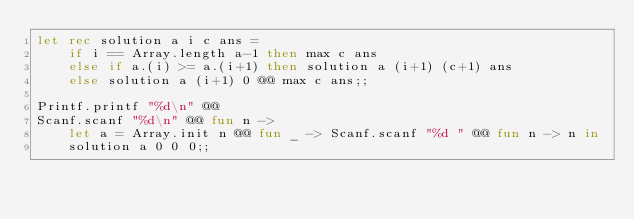<code> <loc_0><loc_0><loc_500><loc_500><_OCaml_>let rec solution a i c ans =
    if i == Array.length a-1 then max c ans
    else if a.(i) >= a.(i+1) then solution a (i+1) (c+1) ans
    else solution a (i+1) 0 @@ max c ans;;

Printf.printf "%d\n" @@
Scanf.scanf "%d\n" @@ fun n ->
    let a = Array.init n @@ fun _ -> Scanf.scanf "%d " @@ fun n -> n in
    solution a 0 0 0;;
</code> 